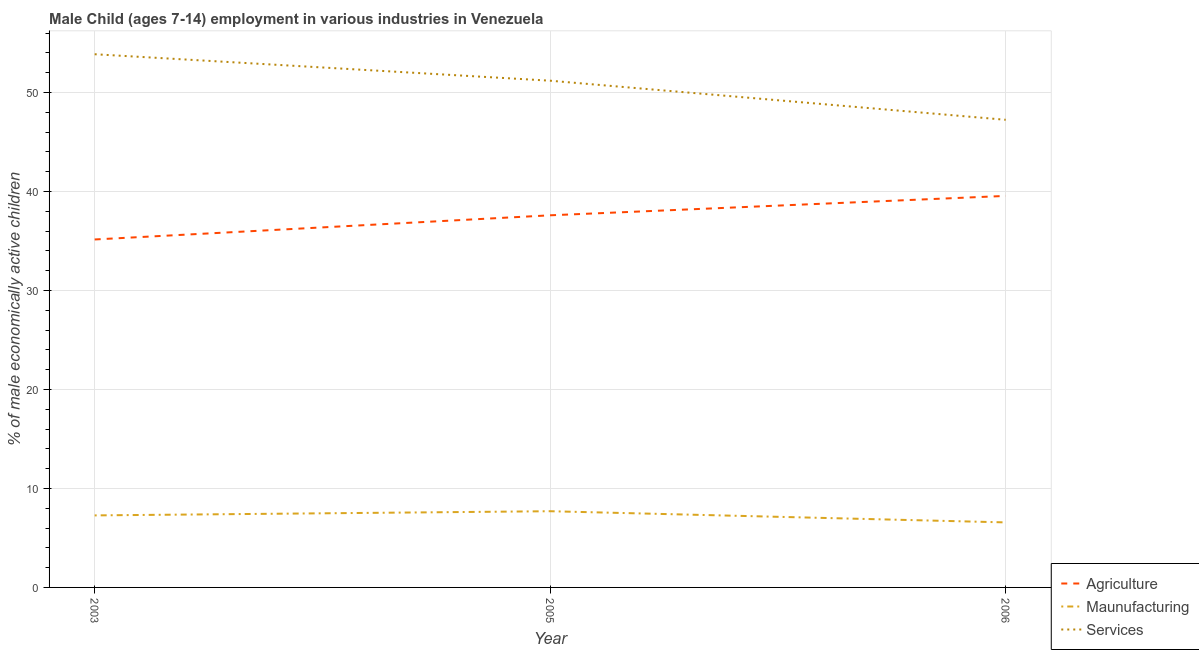Is the number of lines equal to the number of legend labels?
Offer a terse response. Yes. What is the percentage of economically active children in manufacturing in 2003?
Ensure brevity in your answer.  7.28. Across all years, what is the maximum percentage of economically active children in services?
Give a very brief answer. 53.87. Across all years, what is the minimum percentage of economically active children in services?
Your response must be concise. 47.25. In which year was the percentage of economically active children in agriculture minimum?
Your answer should be very brief. 2003. What is the total percentage of economically active children in agriculture in the graph?
Ensure brevity in your answer.  112.32. What is the difference between the percentage of economically active children in manufacturing in 2003 and that in 2005?
Provide a succinct answer. -0.42. What is the difference between the percentage of economically active children in agriculture in 2006 and the percentage of economically active children in services in 2005?
Your answer should be very brief. -11.64. What is the average percentage of economically active children in agriculture per year?
Offer a very short reply. 37.44. In the year 2006, what is the difference between the percentage of economically active children in manufacturing and percentage of economically active children in services?
Ensure brevity in your answer.  -40.68. In how many years, is the percentage of economically active children in services greater than 52 %?
Ensure brevity in your answer.  1. What is the ratio of the percentage of economically active children in services in 2003 to that in 2006?
Provide a succinct answer. 1.14. Is the percentage of economically active children in services in 2003 less than that in 2006?
Give a very brief answer. No. What is the difference between the highest and the second highest percentage of economically active children in manufacturing?
Your answer should be very brief. 0.42. What is the difference between the highest and the lowest percentage of economically active children in services?
Keep it short and to the point. 6.62. Is the sum of the percentage of economically active children in services in 2003 and 2005 greater than the maximum percentage of economically active children in manufacturing across all years?
Give a very brief answer. Yes. Is it the case that in every year, the sum of the percentage of economically active children in agriculture and percentage of economically active children in manufacturing is greater than the percentage of economically active children in services?
Your answer should be compact. No. Is the percentage of economically active children in services strictly greater than the percentage of economically active children in manufacturing over the years?
Offer a terse response. Yes. Is the percentage of economically active children in services strictly less than the percentage of economically active children in agriculture over the years?
Ensure brevity in your answer.  No. How many lines are there?
Your answer should be very brief. 3. How many years are there in the graph?
Ensure brevity in your answer.  3. What is the difference between two consecutive major ticks on the Y-axis?
Keep it short and to the point. 10. Are the values on the major ticks of Y-axis written in scientific E-notation?
Offer a terse response. No. Does the graph contain any zero values?
Offer a very short reply. No. How are the legend labels stacked?
Keep it short and to the point. Vertical. What is the title of the graph?
Provide a short and direct response. Male Child (ages 7-14) employment in various industries in Venezuela. Does "Industrial Nitrous Oxide" appear as one of the legend labels in the graph?
Provide a short and direct response. No. What is the label or title of the X-axis?
Provide a short and direct response. Year. What is the label or title of the Y-axis?
Your answer should be very brief. % of male economically active children. What is the % of male economically active children of Agriculture in 2003?
Make the answer very short. 35.16. What is the % of male economically active children in Maunufacturing in 2003?
Provide a succinct answer. 7.28. What is the % of male economically active children in Services in 2003?
Offer a terse response. 53.87. What is the % of male economically active children of Agriculture in 2005?
Your response must be concise. 37.6. What is the % of male economically active children of Maunufacturing in 2005?
Make the answer very short. 7.7. What is the % of male economically active children in Services in 2005?
Provide a succinct answer. 51.2. What is the % of male economically active children of Agriculture in 2006?
Give a very brief answer. 39.56. What is the % of male economically active children in Maunufacturing in 2006?
Keep it short and to the point. 6.57. What is the % of male economically active children of Services in 2006?
Keep it short and to the point. 47.25. Across all years, what is the maximum % of male economically active children in Agriculture?
Provide a succinct answer. 39.56. Across all years, what is the maximum % of male economically active children of Services?
Offer a terse response. 53.87. Across all years, what is the minimum % of male economically active children in Agriculture?
Provide a succinct answer. 35.16. Across all years, what is the minimum % of male economically active children of Maunufacturing?
Give a very brief answer. 6.57. Across all years, what is the minimum % of male economically active children in Services?
Provide a succinct answer. 47.25. What is the total % of male economically active children in Agriculture in the graph?
Your response must be concise. 112.32. What is the total % of male economically active children in Maunufacturing in the graph?
Your response must be concise. 21.55. What is the total % of male economically active children of Services in the graph?
Give a very brief answer. 152.32. What is the difference between the % of male economically active children of Agriculture in 2003 and that in 2005?
Provide a succinct answer. -2.44. What is the difference between the % of male economically active children of Maunufacturing in 2003 and that in 2005?
Offer a terse response. -0.42. What is the difference between the % of male economically active children in Services in 2003 and that in 2005?
Ensure brevity in your answer.  2.67. What is the difference between the % of male economically active children of Agriculture in 2003 and that in 2006?
Offer a terse response. -4.4. What is the difference between the % of male economically active children in Maunufacturing in 2003 and that in 2006?
Keep it short and to the point. 0.71. What is the difference between the % of male economically active children of Services in 2003 and that in 2006?
Make the answer very short. 6.62. What is the difference between the % of male economically active children of Agriculture in 2005 and that in 2006?
Offer a terse response. -1.96. What is the difference between the % of male economically active children of Maunufacturing in 2005 and that in 2006?
Your answer should be compact. 1.13. What is the difference between the % of male economically active children of Services in 2005 and that in 2006?
Your response must be concise. 3.95. What is the difference between the % of male economically active children in Agriculture in 2003 and the % of male economically active children in Maunufacturing in 2005?
Ensure brevity in your answer.  27.46. What is the difference between the % of male economically active children of Agriculture in 2003 and the % of male economically active children of Services in 2005?
Make the answer very short. -16.04. What is the difference between the % of male economically active children of Maunufacturing in 2003 and the % of male economically active children of Services in 2005?
Keep it short and to the point. -43.92. What is the difference between the % of male economically active children of Agriculture in 2003 and the % of male economically active children of Maunufacturing in 2006?
Your response must be concise. 28.59. What is the difference between the % of male economically active children of Agriculture in 2003 and the % of male economically active children of Services in 2006?
Provide a short and direct response. -12.09. What is the difference between the % of male economically active children of Maunufacturing in 2003 and the % of male economically active children of Services in 2006?
Keep it short and to the point. -39.97. What is the difference between the % of male economically active children of Agriculture in 2005 and the % of male economically active children of Maunufacturing in 2006?
Your answer should be very brief. 31.03. What is the difference between the % of male economically active children in Agriculture in 2005 and the % of male economically active children in Services in 2006?
Offer a very short reply. -9.65. What is the difference between the % of male economically active children of Maunufacturing in 2005 and the % of male economically active children of Services in 2006?
Keep it short and to the point. -39.55. What is the average % of male economically active children of Agriculture per year?
Offer a terse response. 37.44. What is the average % of male economically active children in Maunufacturing per year?
Provide a succinct answer. 7.18. What is the average % of male economically active children in Services per year?
Provide a short and direct response. 50.77. In the year 2003, what is the difference between the % of male economically active children in Agriculture and % of male economically active children in Maunufacturing?
Make the answer very short. 27.88. In the year 2003, what is the difference between the % of male economically active children in Agriculture and % of male economically active children in Services?
Keep it short and to the point. -18.72. In the year 2003, what is the difference between the % of male economically active children of Maunufacturing and % of male economically active children of Services?
Offer a very short reply. -46.6. In the year 2005, what is the difference between the % of male economically active children of Agriculture and % of male economically active children of Maunufacturing?
Make the answer very short. 29.9. In the year 2005, what is the difference between the % of male economically active children of Maunufacturing and % of male economically active children of Services?
Your answer should be very brief. -43.5. In the year 2006, what is the difference between the % of male economically active children of Agriculture and % of male economically active children of Maunufacturing?
Give a very brief answer. 32.99. In the year 2006, what is the difference between the % of male economically active children of Agriculture and % of male economically active children of Services?
Ensure brevity in your answer.  -7.69. In the year 2006, what is the difference between the % of male economically active children of Maunufacturing and % of male economically active children of Services?
Provide a succinct answer. -40.68. What is the ratio of the % of male economically active children in Agriculture in 2003 to that in 2005?
Your response must be concise. 0.94. What is the ratio of the % of male economically active children of Maunufacturing in 2003 to that in 2005?
Your answer should be compact. 0.95. What is the ratio of the % of male economically active children of Services in 2003 to that in 2005?
Provide a short and direct response. 1.05. What is the ratio of the % of male economically active children in Agriculture in 2003 to that in 2006?
Provide a succinct answer. 0.89. What is the ratio of the % of male economically active children of Maunufacturing in 2003 to that in 2006?
Your answer should be very brief. 1.11. What is the ratio of the % of male economically active children of Services in 2003 to that in 2006?
Offer a terse response. 1.14. What is the ratio of the % of male economically active children of Agriculture in 2005 to that in 2006?
Your answer should be very brief. 0.95. What is the ratio of the % of male economically active children of Maunufacturing in 2005 to that in 2006?
Your response must be concise. 1.17. What is the ratio of the % of male economically active children of Services in 2005 to that in 2006?
Give a very brief answer. 1.08. What is the difference between the highest and the second highest % of male economically active children in Agriculture?
Give a very brief answer. 1.96. What is the difference between the highest and the second highest % of male economically active children of Maunufacturing?
Offer a very short reply. 0.42. What is the difference between the highest and the second highest % of male economically active children in Services?
Your answer should be compact. 2.67. What is the difference between the highest and the lowest % of male economically active children of Agriculture?
Make the answer very short. 4.4. What is the difference between the highest and the lowest % of male economically active children in Maunufacturing?
Your answer should be compact. 1.13. What is the difference between the highest and the lowest % of male economically active children in Services?
Make the answer very short. 6.62. 